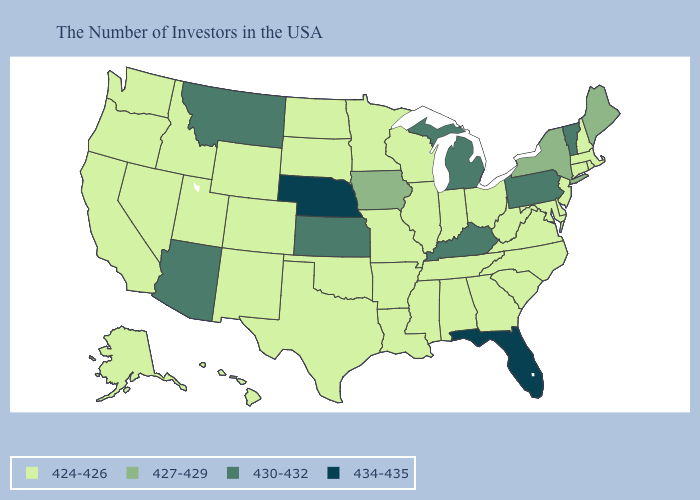What is the highest value in the Northeast ?
Keep it brief. 430-432. What is the lowest value in the West?
Give a very brief answer. 424-426. Which states have the highest value in the USA?
Write a very short answer. Florida, Nebraska. Which states hav the highest value in the West?
Give a very brief answer. Montana, Arizona. Does Tennessee have the same value as Michigan?
Keep it brief. No. What is the value of Delaware?
Short answer required. 424-426. Does Utah have the highest value in the USA?
Answer briefly. No. Among the states that border West Virginia , which have the highest value?
Give a very brief answer. Pennsylvania, Kentucky. Does Vermont have a higher value than Montana?
Answer briefly. No. Does North Carolina have the same value as Minnesota?
Short answer required. Yes. Name the states that have a value in the range 424-426?
Quick response, please. Massachusetts, Rhode Island, New Hampshire, Connecticut, New Jersey, Delaware, Maryland, Virginia, North Carolina, South Carolina, West Virginia, Ohio, Georgia, Indiana, Alabama, Tennessee, Wisconsin, Illinois, Mississippi, Louisiana, Missouri, Arkansas, Minnesota, Oklahoma, Texas, South Dakota, North Dakota, Wyoming, Colorado, New Mexico, Utah, Idaho, Nevada, California, Washington, Oregon, Alaska, Hawaii. What is the highest value in states that border Utah?
Keep it brief. 430-432. Does Delaware have the highest value in the USA?
Short answer required. No. Is the legend a continuous bar?
Keep it brief. No. Among the states that border Vermont , which have the highest value?
Answer briefly. New York. 